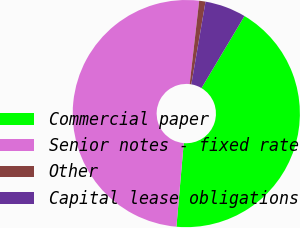<chart> <loc_0><loc_0><loc_500><loc_500><pie_chart><fcel>Commercial paper<fcel>Senior notes - fixed rate<fcel>Other<fcel>Capital lease obligations<nl><fcel>42.83%<fcel>50.43%<fcel>0.9%<fcel>5.85%<nl></chart> 